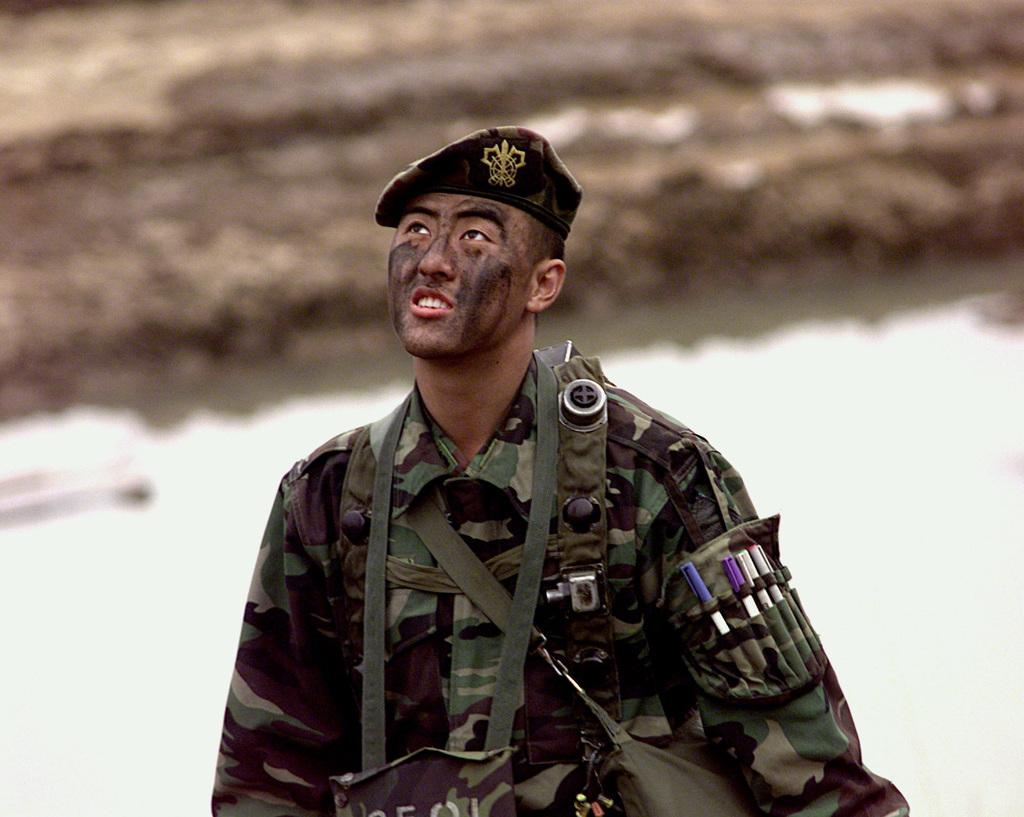What can be seen in the image? There is a person in the image. What is the person wearing? The person is wearing a uniform. What items does the person have? The person has pens and is carrying bags. How is the person wearing a bag? The person is wearing a bag on their body. What can be observed about the background of the image? The background of the image is blurry. What type of vegetable is the person holding in the image? There is no vegetable present in the image; the person has pens and is carrying bags. 